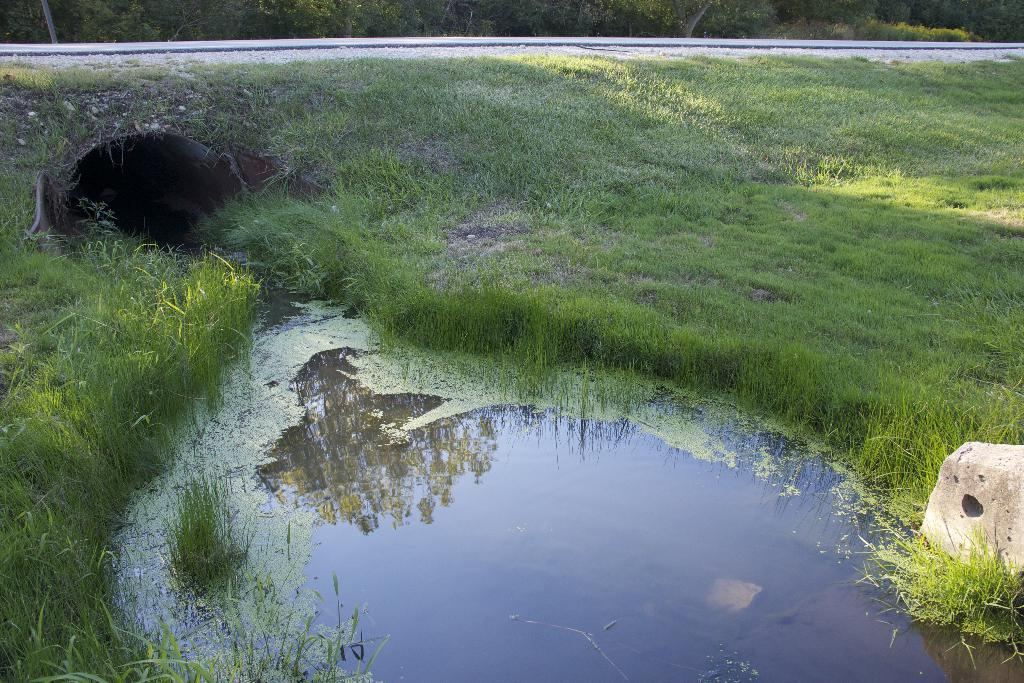What is the main feature of the image? There is a hole in the center of the image. What type of structure can be seen in the image? There is a white solid structure in the image. What type of vegetation is present in the image? Grass and plants are visible in the image. What natural element is present in the image? There is water in the image. Are there any other objects in the image besides the hole, structure, vegetation, and water? Yes, there are a few other objects in the image. What type of plantation can be seen in the image? There is no plantation present in the image. What type of mine is visible in the image? There is no mine present in the image. 